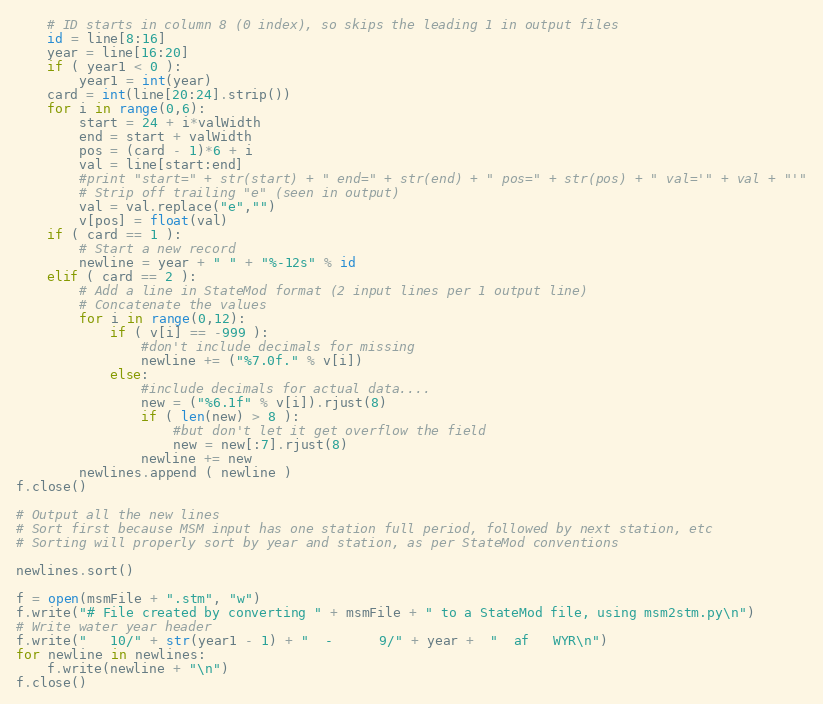Convert code to text. <code><loc_0><loc_0><loc_500><loc_500><_Python_>    # ID starts in column 8 (0 index), so skips the leading 1 in output files
    id = line[8:16]
    year = line[16:20]
    if ( year1 < 0 ):
        year1 = int(year)
    card = int(line[20:24].strip())
    for i in range(0,6):
        start = 24 + i*valWidth
        end = start + valWidth
        pos = (card - 1)*6 + i
        val = line[start:end]
        #print "start=" + str(start) + " end=" + str(end) + " pos=" + str(pos) + " val='" + val + "'"
        # Strip off trailing "e" (seen in output)
        val = val.replace("e","")
        v[pos] = float(val)
    if ( card == 1 ):
        # Start a new record
        newline = year + " " + "%-12s" % id 
    elif ( card == 2 ):
        # Add a line in StateMod format (2 input lines per 1 output line)
        # Concatenate the values
        for i in range(0,12):
            if ( v[i] == -999 ):
                #don't include decimals for missing
                newline += ("%7.0f." % v[i])
            else:
                #include decimals for actual data....
                new = ("%6.1f" % v[i]).rjust(8)
                if ( len(new) > 8 ):
                    #but don't let it get overflow the field
                    new = new[:7].rjust(8)
                newline += new
        newlines.append ( newline )
f.close()

# Output all the new lines
# Sort first because MSM input has one station full period, followed by next station, etc
# Sorting will properly sort by year and station, as per StateMod conventions

newlines.sort()

f = open(msmFile + ".stm", "w")
f.write("# File created by converting " + msmFile + " to a StateMod file, using msm2stm.py\n")
# Write water year header
f.write("   10/" + str(year1 - 1) + "  -      9/" + year +  "  af   WYR\n")
for newline in newlines:
    f.write(newline + "\n")
f.close()
</code> 